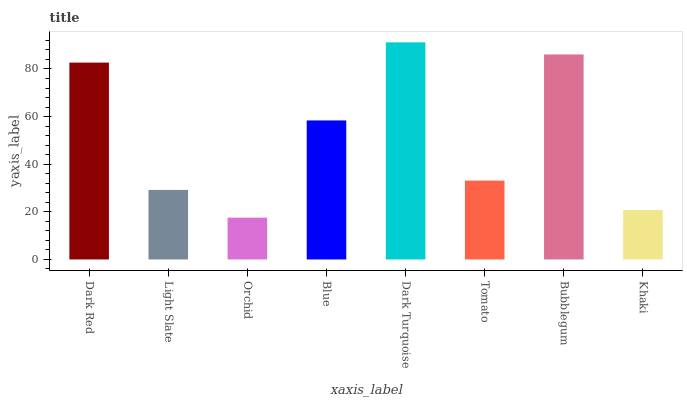Is Orchid the minimum?
Answer yes or no. Yes. Is Dark Turquoise the maximum?
Answer yes or no. Yes. Is Light Slate the minimum?
Answer yes or no. No. Is Light Slate the maximum?
Answer yes or no. No. Is Dark Red greater than Light Slate?
Answer yes or no. Yes. Is Light Slate less than Dark Red?
Answer yes or no. Yes. Is Light Slate greater than Dark Red?
Answer yes or no. No. Is Dark Red less than Light Slate?
Answer yes or no. No. Is Blue the high median?
Answer yes or no. Yes. Is Tomato the low median?
Answer yes or no. Yes. Is Tomato the high median?
Answer yes or no. No. Is Blue the low median?
Answer yes or no. No. 